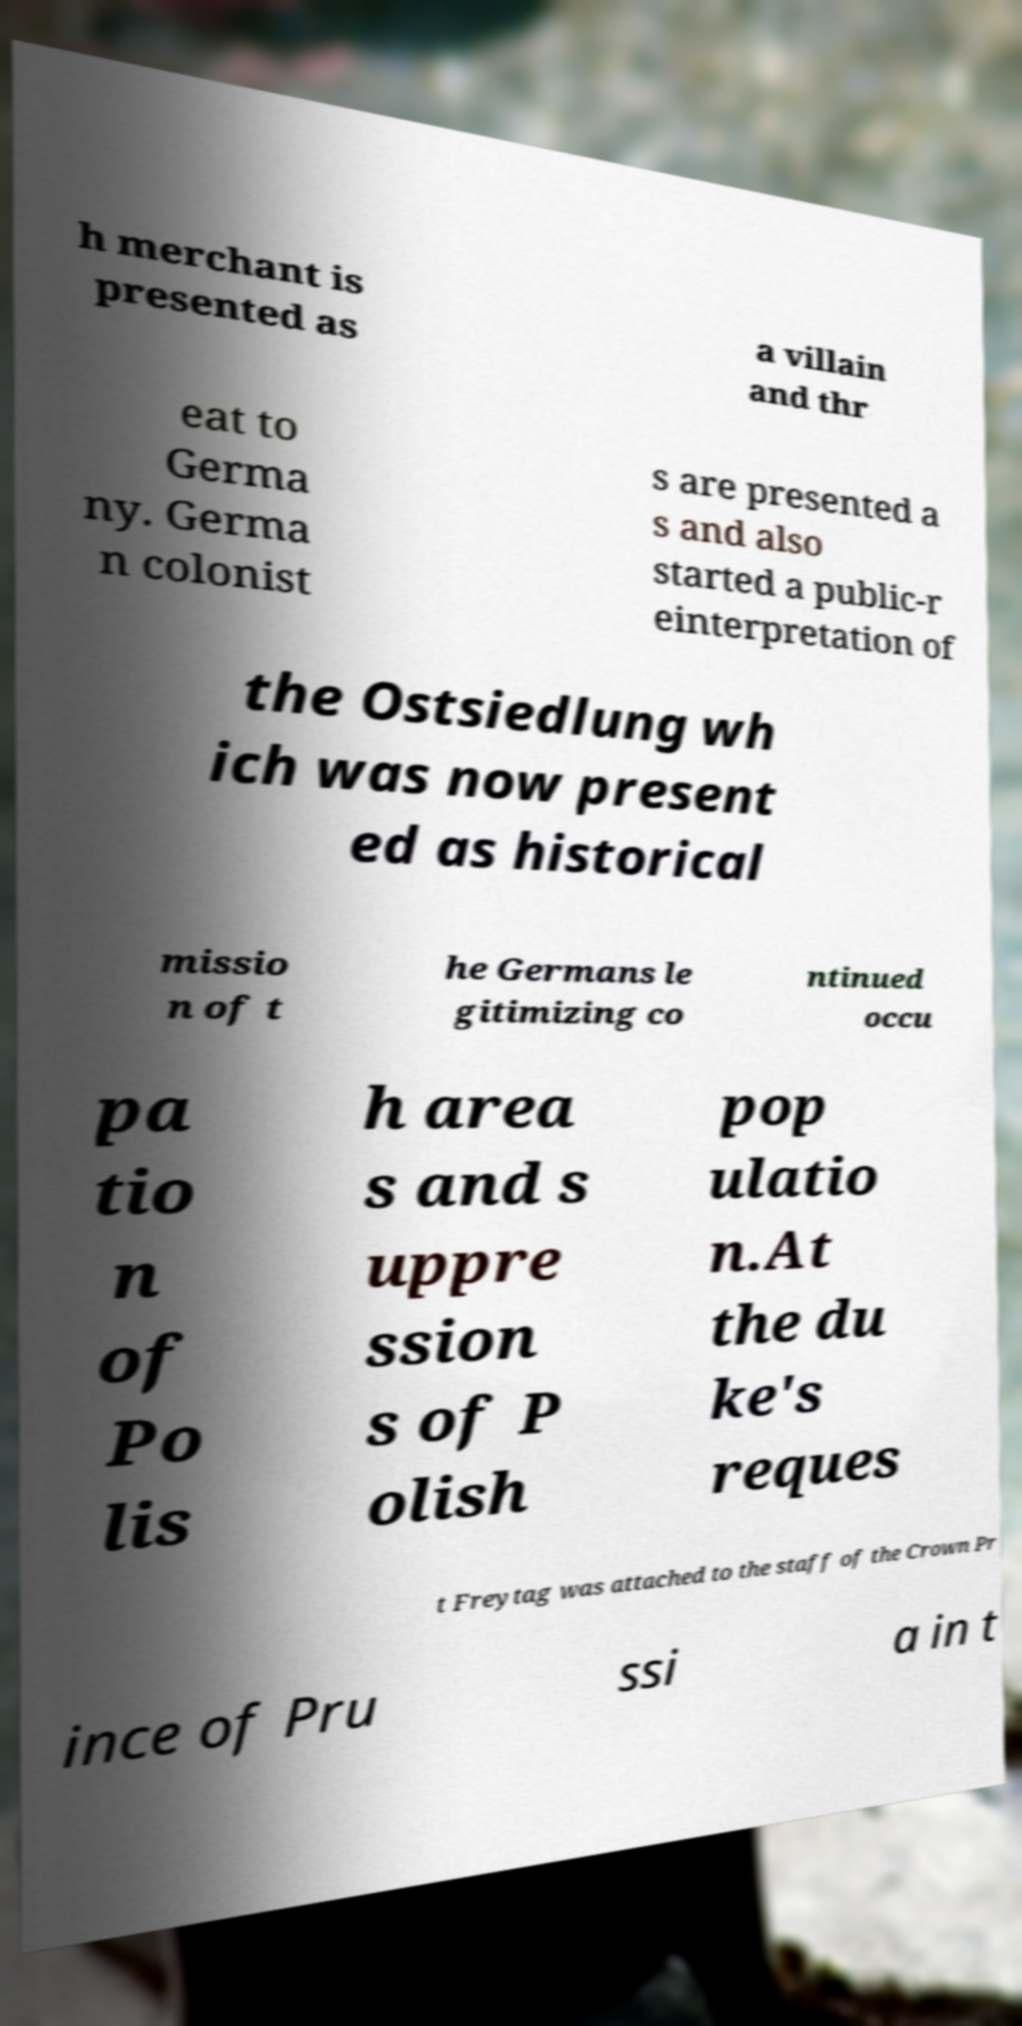For documentation purposes, I need the text within this image transcribed. Could you provide that? h merchant is presented as a villain and thr eat to Germa ny. Germa n colonist s are presented a s and also started a public-r einterpretation of the Ostsiedlung wh ich was now present ed as historical missio n of t he Germans le gitimizing co ntinued occu pa tio n of Po lis h area s and s uppre ssion s of P olish pop ulatio n.At the du ke's reques t Freytag was attached to the staff of the Crown Pr ince of Pru ssi a in t 